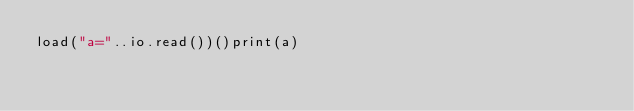<code> <loc_0><loc_0><loc_500><loc_500><_Lua_>load("a="..io.read())()print(a)</code> 